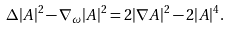Convert formula to latex. <formula><loc_0><loc_0><loc_500><loc_500>\Delta | A | ^ { 2 } - \nabla _ { \omega } | A | ^ { 2 } = 2 | \nabla A | ^ { 2 } - 2 | A | ^ { 4 } .</formula> 